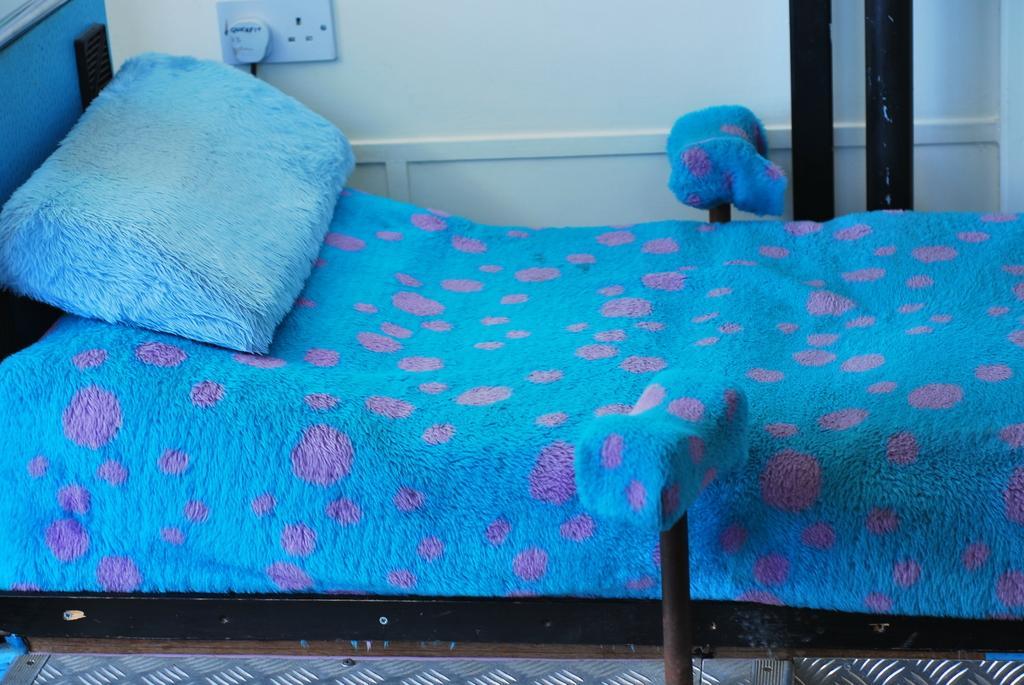Please provide a concise description of this image. This picture shows a bed and a pillow 